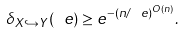Convert formula to latex. <formula><loc_0><loc_0><loc_500><loc_500>\delta _ { X \hookrightarrow Y } ( \ e ) \geq e ^ { - ( n / \ e ) ^ { O ( n ) } } .</formula> 